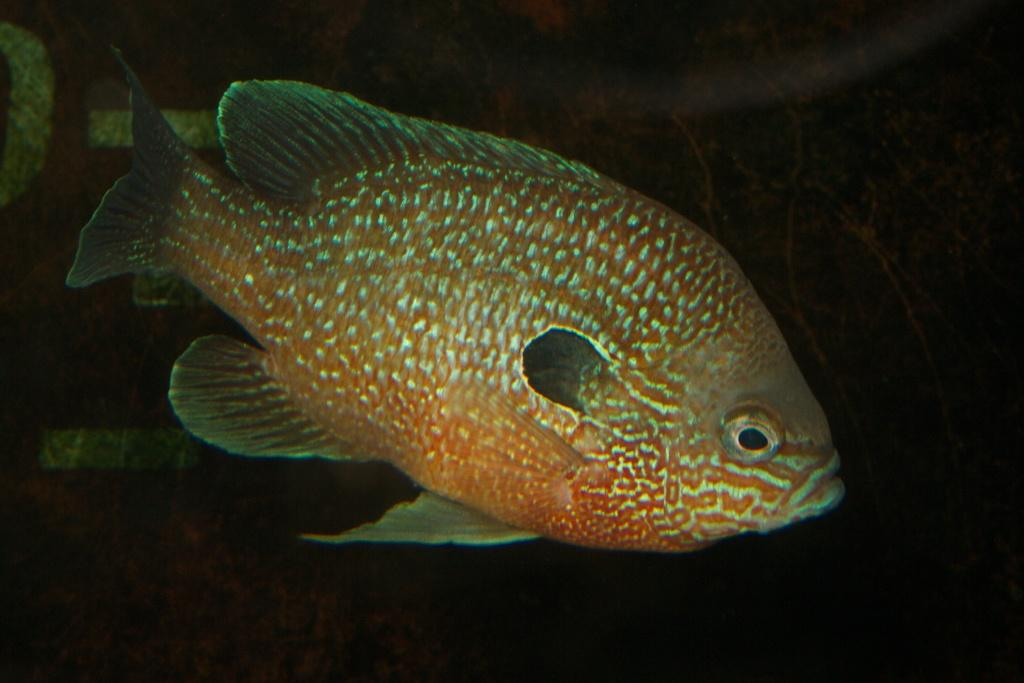What type of animal is in the image? There is a fish in the image. What color is the fish? The fish is orange in color. Where is the fish located? The fish is in water. What is the color of the background in the image? The background of the image is dark. Can you see any robins eating berries in the image? There are no robins or berries present in the image; it features a fish in water with a dark background. 